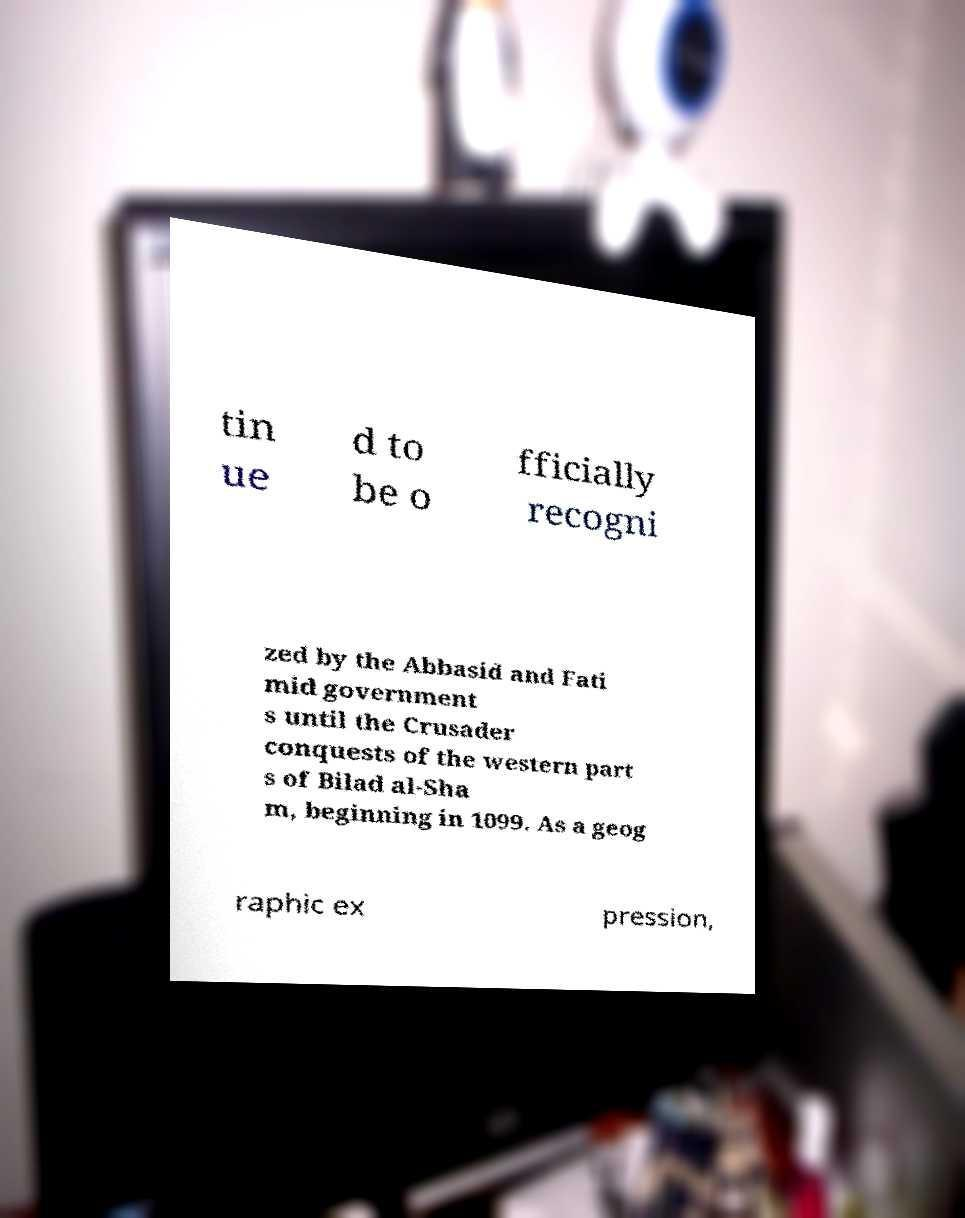I need the written content from this picture converted into text. Can you do that? tin ue d to be o fficially recogni zed by the Abbasid and Fati mid government s until the Crusader conquests of the western part s of Bilad al-Sha m, beginning in 1099. As a geog raphic ex pression, 